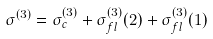Convert formula to latex. <formula><loc_0><loc_0><loc_500><loc_500>\sigma ^ { ( 3 ) } = \sigma _ { c } ^ { ( 3 ) } + \sigma _ { f l } ^ { ( 3 ) } ( 2 ) + \sigma _ { f l } ^ { ( 3 ) } ( 1 ) \,</formula> 